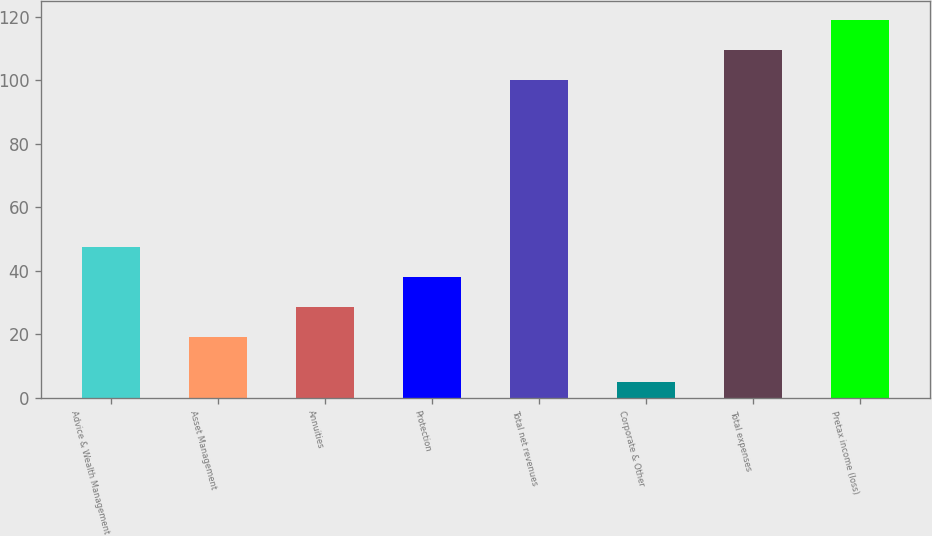<chart> <loc_0><loc_0><loc_500><loc_500><bar_chart><fcel>Advice & Wealth Management<fcel>Asset Management<fcel>Annuities<fcel>Protection<fcel>Total net revenues<fcel>Corporate & Other<fcel>Total expenses<fcel>Pretax income (loss)<nl><fcel>47.5<fcel>19<fcel>28.5<fcel>38<fcel>100<fcel>5<fcel>109.5<fcel>119<nl></chart> 